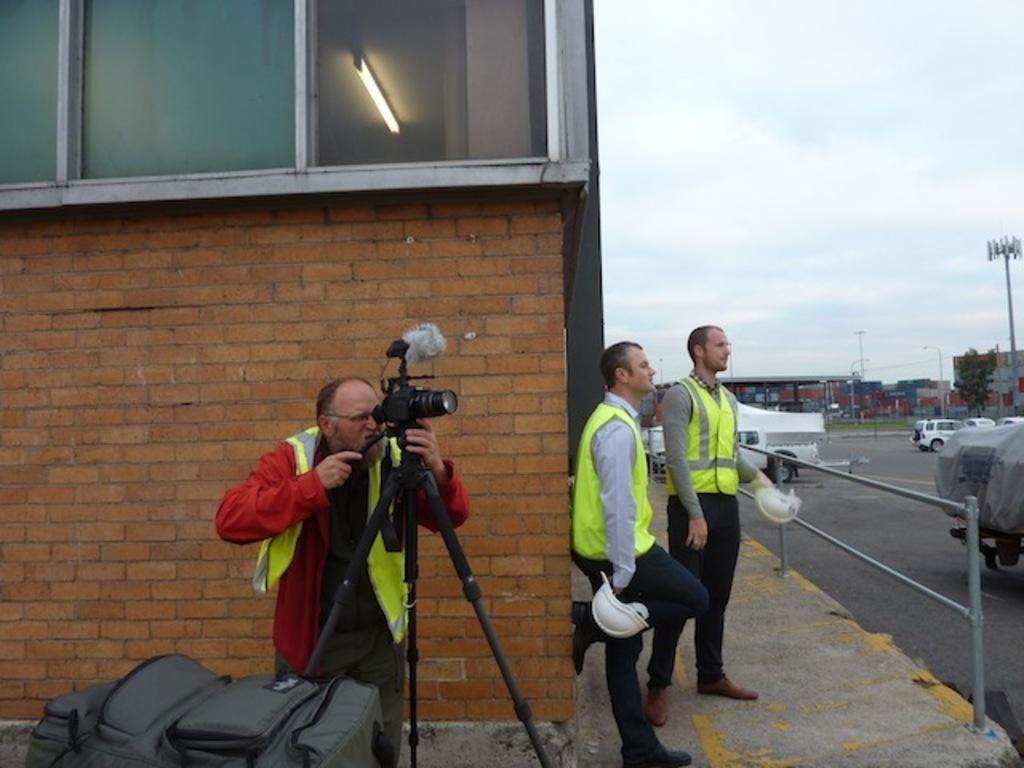Can you describe this image briefly? In this image we can see this person wearing coat is standing near the camera which is fixed to the tripod stand. Here we can see the bag and these two persons are standing here and holding helmets in their hands. Here we can see the brick wall, glass windows through which we can see the tube-light, we can see vehicles on the road, we can tent, light poles, trees and the sky in the background. 